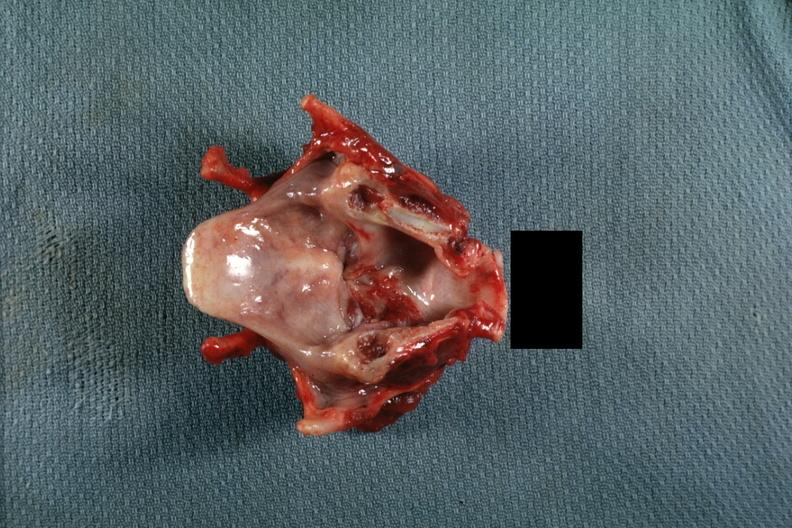does this image show excellent granular lesion on true cord extending inferior?
Answer the question using a single word or phrase. Yes 